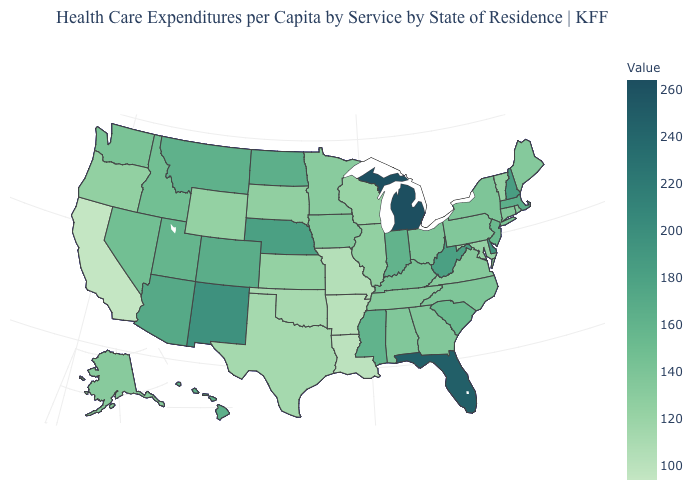Which states have the lowest value in the USA?
Quick response, please. California. Does Louisiana have the lowest value in the South?
Quick response, please. Yes. Which states have the highest value in the USA?
Short answer required. Michigan. 